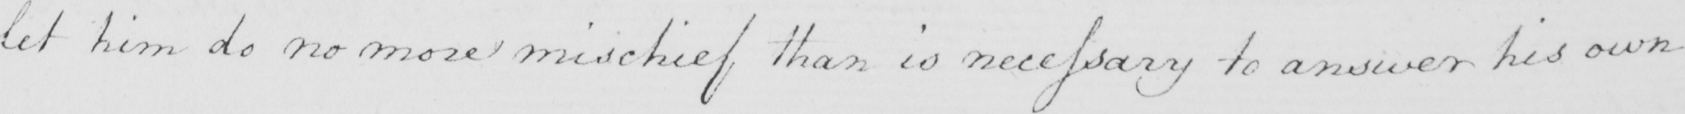Transcribe the text shown in this historical manuscript line. let him do no more mischief than is necessary to answer his own 